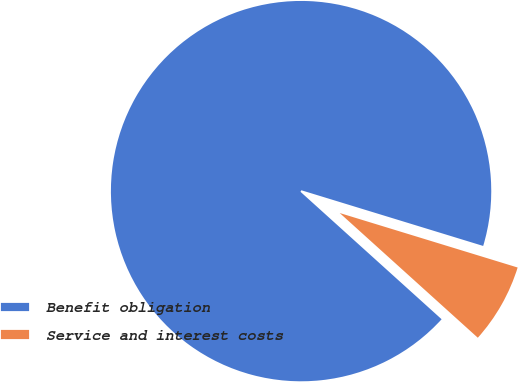Convert chart. <chart><loc_0><loc_0><loc_500><loc_500><pie_chart><fcel>Benefit obligation<fcel>Service and interest costs<nl><fcel>93.04%<fcel>6.96%<nl></chart> 